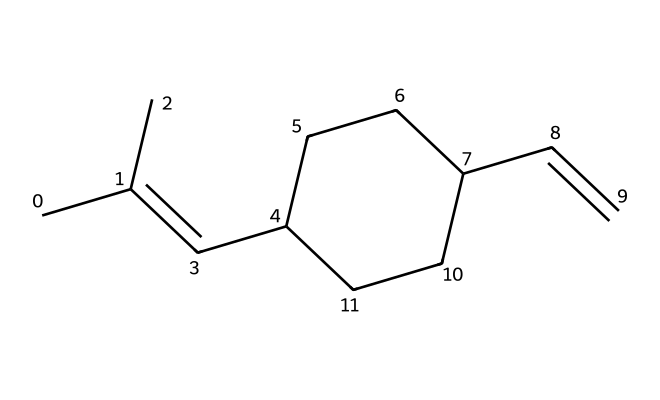What is the total number of carbon atoms in this monomer? By inspecting the SMILES representation, we can count the carbon atoms represented by the 'C' characters. The structure has a total of 12 carbon atoms.
Answer: 12 How many double bonds are present in this structure? In the SMILES notation, double bonds are indicated by '='. There are two '=' symbols in this representation, indicating that there are two double bonds in the structure.
Answer: 2 What type of polymer results from the polymerization of this monomer? Styrene-butadiene rubber results from the polymerization of styrene and butadiene, as this monomer is a combination of their structures.
Answer: styrene-butadiene rubber Does this chemical structure likely contain functional groups? The structure is primarily composed of hydrocarbons with alkene functionalities, represented by its double bonds. However, there are no distinct functional groups like hydroxyl or carboxylic acids present here.
Answer: no What is the significance of the cycloalkane present in this structure? The presence of the cycloalkane (a cyclic structure) contributes to the rubbery properties of the styrene-butadiene rubber, allowing for elasticity and flexibility.
Answer: elasticity Which part of this monomer contributes to its waterproof properties? The hydrophobic nature of the carbon backbone and the presence of non-polar double bonds contribute to the waterproof characteristics of this rubber material.
Answer: carbon backbone 